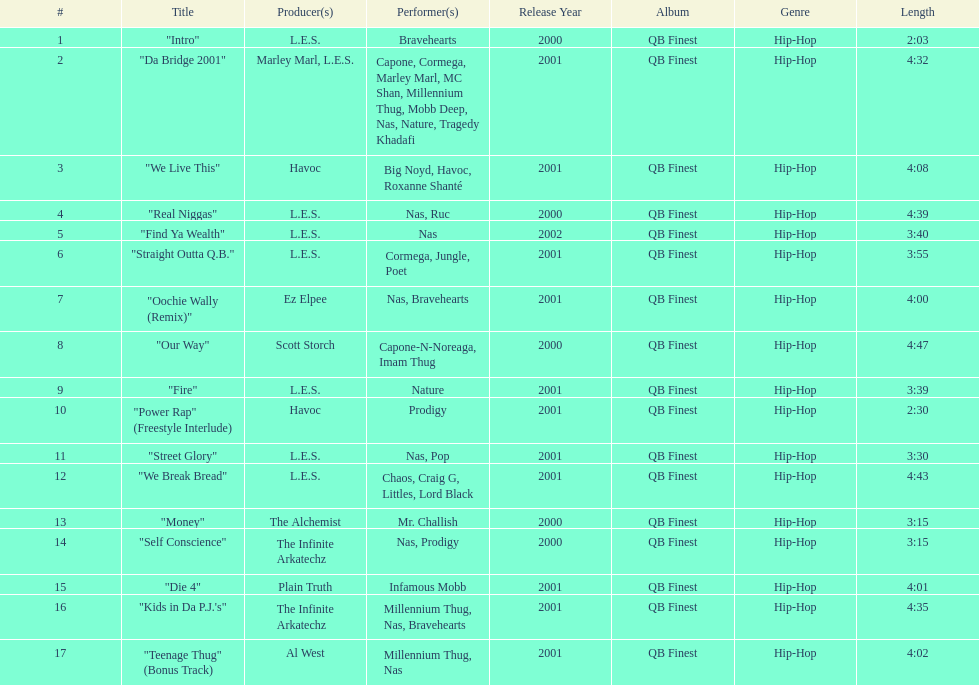How many tunes are no less than 4 minutes long? 9. 